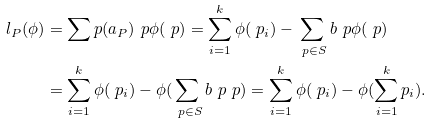<formula> <loc_0><loc_0><loc_500><loc_500>l _ { P } ( \phi ) & = { \sum _ { \ } p ( a _ { P } ) _ { \ } p \phi ( \ p ) = \sum _ { i = 1 } ^ { k } \phi ( \ p _ { i } ) - \sum _ { \ p \in S } b _ { \ } p \phi ( \ p ) } \\ & = { \sum _ { i = 1 } ^ { k } \phi ( \ p _ { i } ) - \phi ( \sum _ { \ p \in S } b _ { \ } p \ p ) = \sum _ { i = 1 } ^ { k } \phi ( \ p _ { i } ) - \phi ( \sum _ { i = 1 } ^ { k } p _ { i } ) . }</formula> 